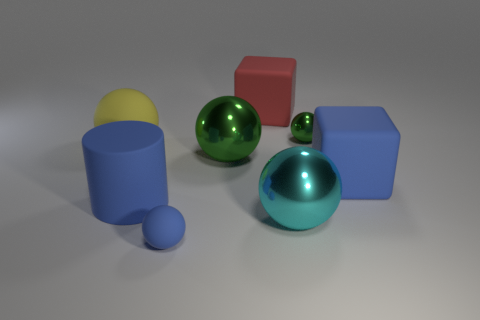There is another metallic ball that is the same size as the blue sphere; what is its color? The color of the metallic ball that is the same size as the blue sphere is indeed green. It has a reflective surface that mirrors the surrounding shapes and colors, giving it a vibrant look. 